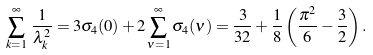<formula> <loc_0><loc_0><loc_500><loc_500>\sum _ { k = 1 } ^ { \infty } \, \frac { 1 } { \lambda _ { k } ^ { 2 } } = 3 \sigma _ { 4 } ( 0 ) + 2 \sum _ { \nu = 1 } ^ { \infty } \sigma _ { 4 } ( \nu ) = \frac { 3 } { 3 2 } + \frac { 1 } { 8 } \left ( \frac { \pi ^ { 2 } } { 6 } - \frac { 3 } { 2 } \right ) .</formula> 